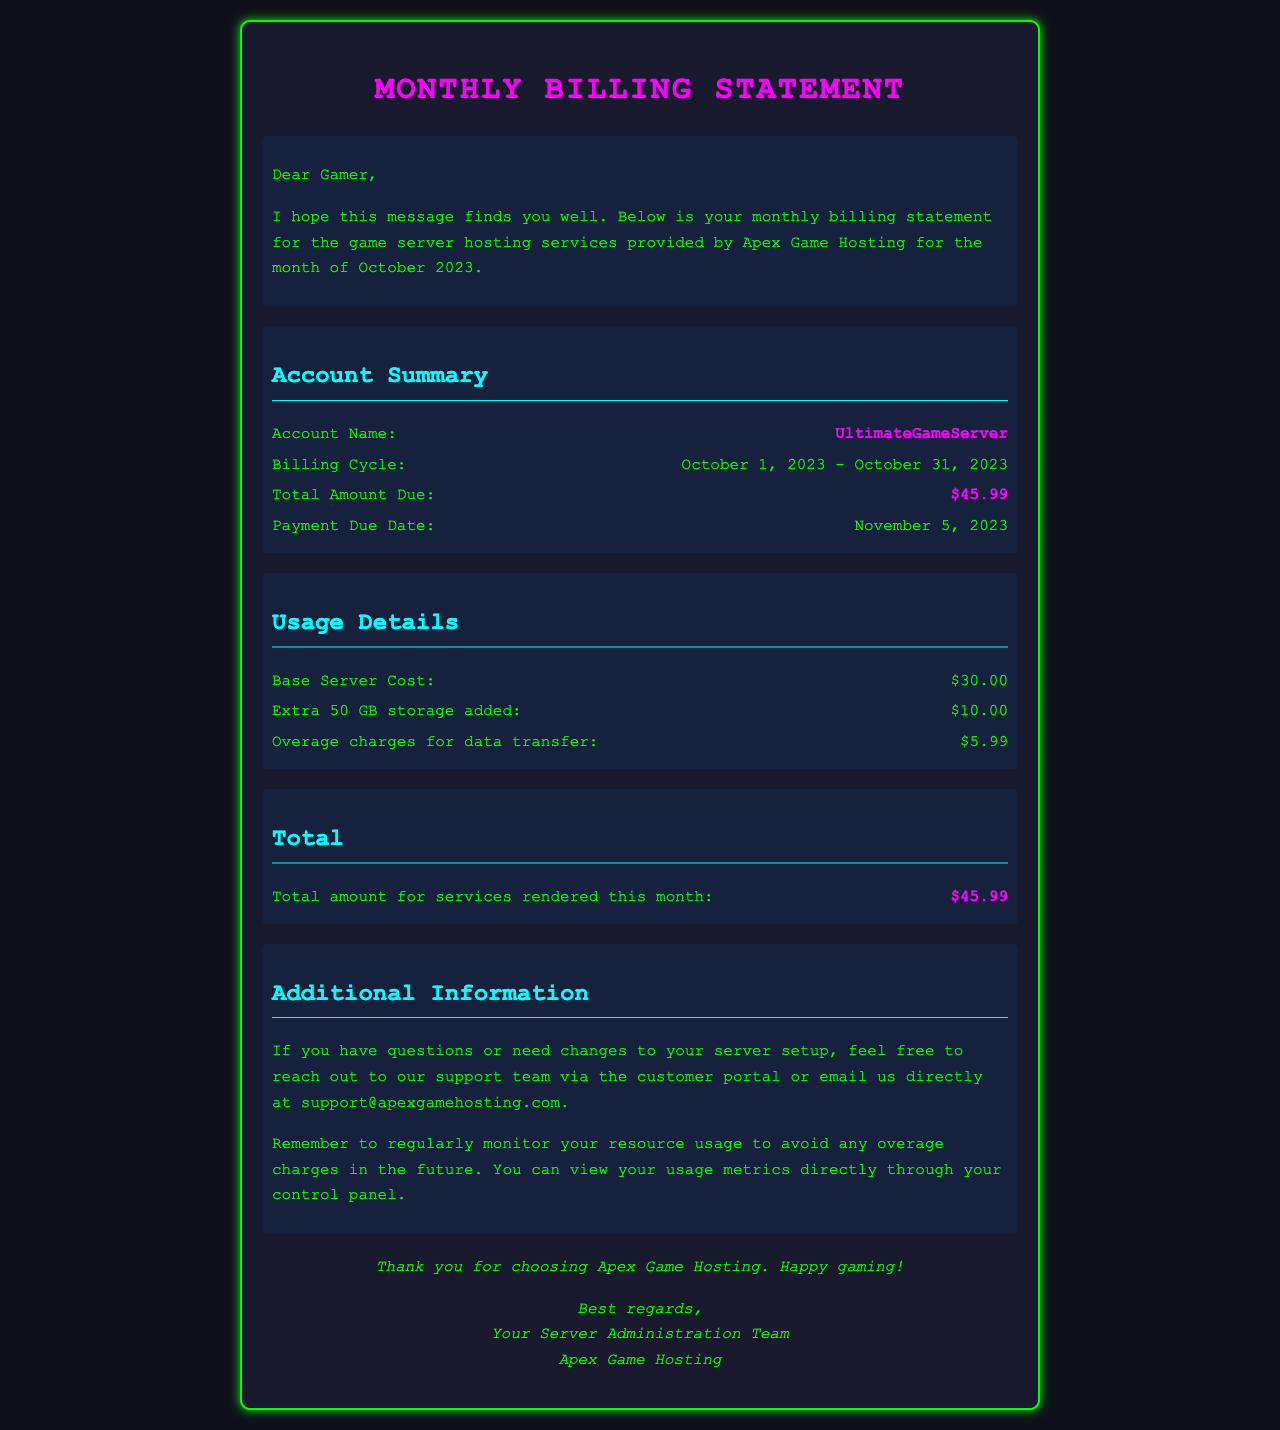What is the account name? The account name is provided in the Account Summary section of the document.
Answer: UltimateGameServer What is the total amount due? The total amount due is stated in the Account Summary section of the document.
Answer: $45.99 What is the billing cycle for this month? The billing cycle details can be found in the Account Summary section.
Answer: October 1, 2023 - October 31, 2023 What are the overage charges for data transfer? Overage charges are specifically mentioned in the Usage Details section of the document.
Answer: $5.99 When is the payment due date? The due date for payment is listed in the Account Summary.
Answer: November 5, 2023 How much was charged for extra storage? The charge for extra storage is listed in the Usage Details section.
Answer: $10.00 What is the base server cost? The base server cost is detailed within the Usage Details section of the document.
Answer: $30.00 What can you do if you have questions about your server setup? The document provides guidance on what to do if you have questions about your server setup.
Answer: Reach out to our support team What reminder is given in the Additional Information section? The Additional Information section includes reminders about usage monitoring to avoid charges.
Answer: Regularly monitor your resource usage 